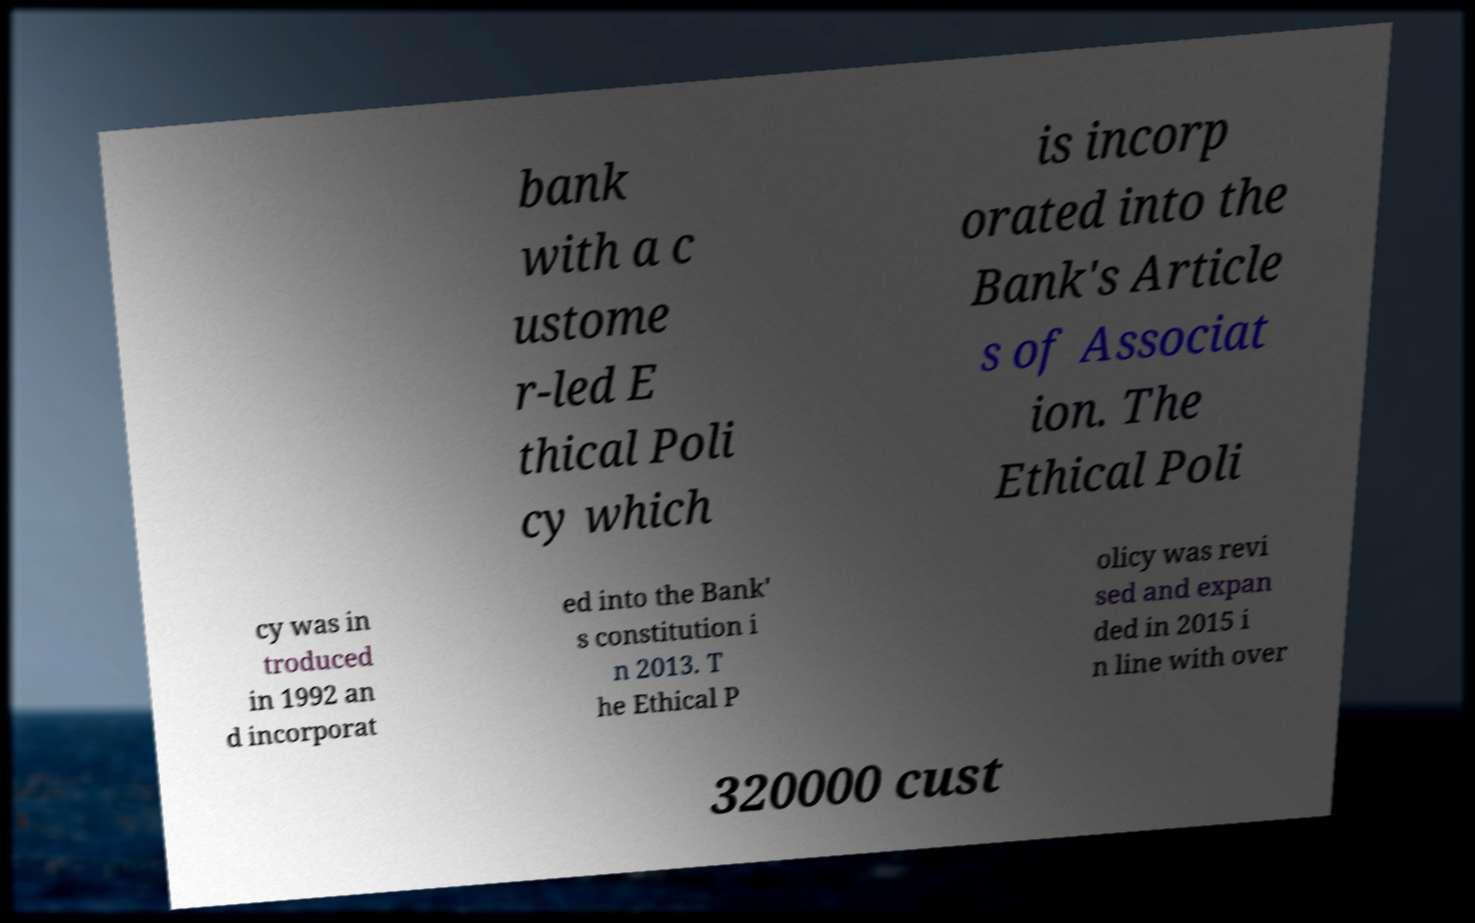Can you accurately transcribe the text from the provided image for me? bank with a c ustome r-led E thical Poli cy which is incorp orated into the Bank's Article s of Associat ion. The Ethical Poli cy was in troduced in 1992 an d incorporat ed into the Bank' s constitution i n 2013. T he Ethical P olicy was revi sed and expan ded in 2015 i n line with over 320000 cust 